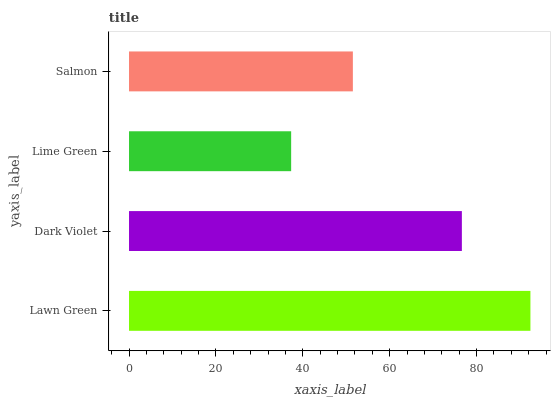Is Lime Green the minimum?
Answer yes or no. Yes. Is Lawn Green the maximum?
Answer yes or no. Yes. Is Dark Violet the minimum?
Answer yes or no. No. Is Dark Violet the maximum?
Answer yes or no. No. Is Lawn Green greater than Dark Violet?
Answer yes or no. Yes. Is Dark Violet less than Lawn Green?
Answer yes or no. Yes. Is Dark Violet greater than Lawn Green?
Answer yes or no. No. Is Lawn Green less than Dark Violet?
Answer yes or no. No. Is Dark Violet the high median?
Answer yes or no. Yes. Is Salmon the low median?
Answer yes or no. Yes. Is Lawn Green the high median?
Answer yes or no. No. Is Lawn Green the low median?
Answer yes or no. No. 